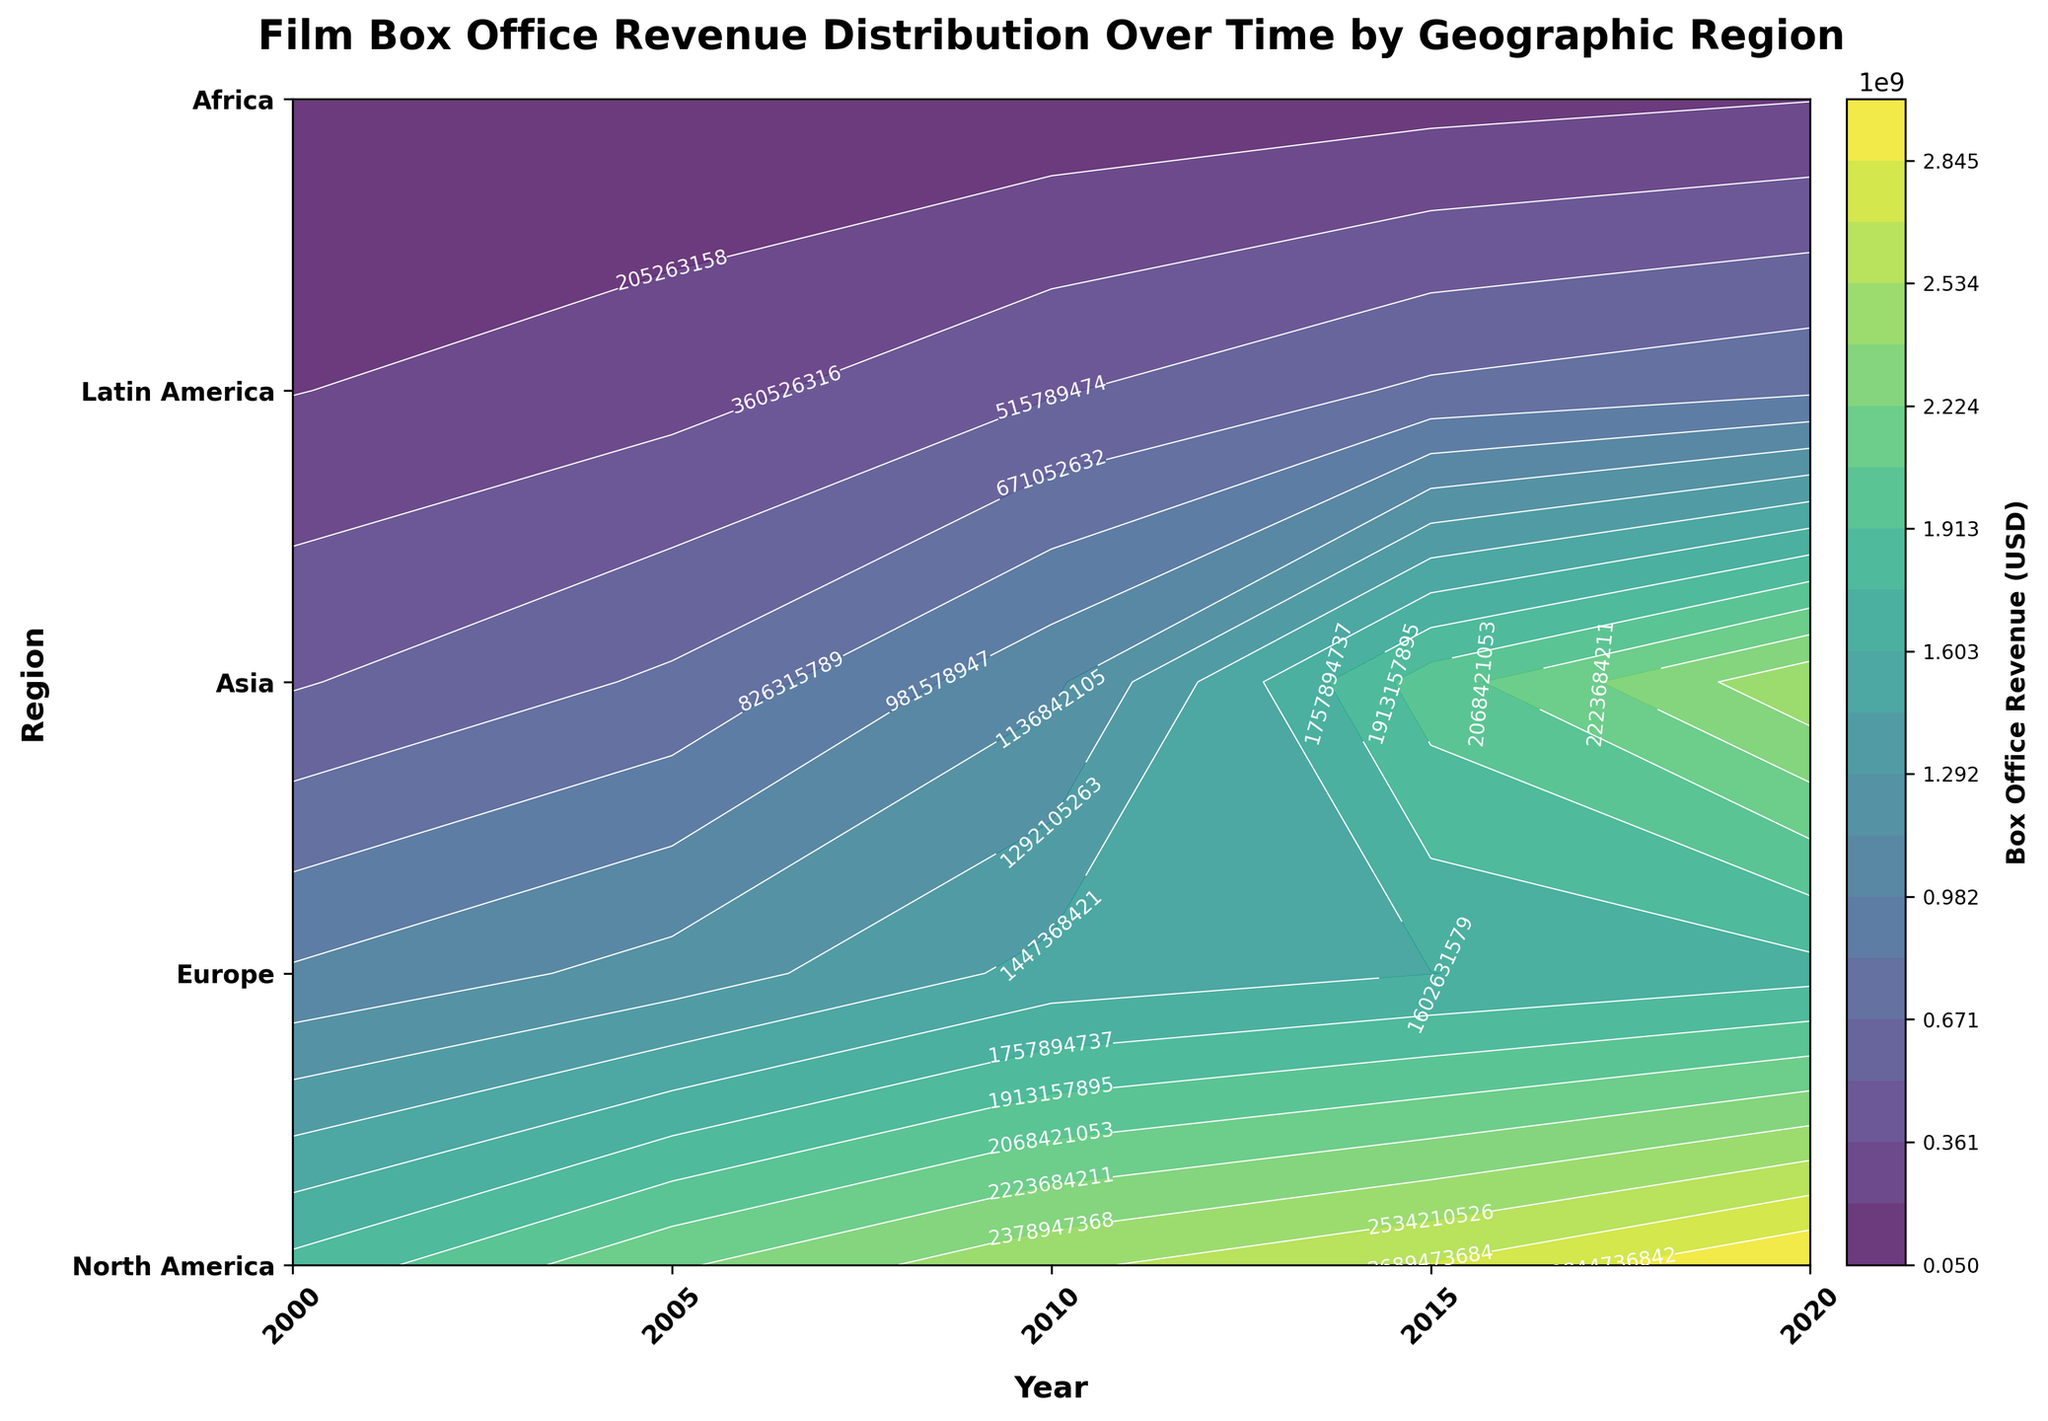What is the title of the plot? The title is usually the largest text at the top of the figure. It gives an overview of what the plot represents.
Answer: Film Box Office Revenue Distribution Over Time by Geographic Region Which region had the highest box office revenue in 2020? To find this, look at the box office revenue values along the 2020 axis and identify the highest value. Then find the corresponding region on the y-axis.
Answer: North America How did the box office revenue in Asia change from 2010 to 2020? Compare the contour levels or values of box office revenue for Asia between 2010 and 2020. Subtract the 2010 value from the 2020 value.
Answer: Increased Which year saw the highest revenue across all regions? Look for the year that has the highest maximum contour value among all regions combined.
Answer: 2020 What is the trend of box office revenue in Latin America from 2000 to 2020? Observe the contour levels for Latin America from 2000 to 2020. You can see the pattern of increase or decrease by comparing the values across the years.
Answer: Mostly increasing What region had the smallest increase in box office revenue from 2000 to 2020? Calculate the difference in box office revenue for each region from 2000 to 2020. Find the region with the smallest value.
Answer: Africa How does the box office revenue in Europe compare to Asia in 2015? Compare the contour levels or values of box office revenue in Europe and Asia in 2015. Look for which one is higher.
Answer: Europe is less than Asia Which regions show a consistent increase in box office revenue from 2000 to 2020? Analyze the contour levels for all regions across the given years. Identify regions with a steady upward trend throughout this period.
Answer: North America, Asia, Latin America Compare the box office revenue trend of North America and Europe from 2000 to 2020. Examine and compare the contour levels of box office revenue for North America and Europe over the years. Look at the changes in values to identify trends.
Answer: Both increase, but North America increases more What is the range of box office revenue values displayed in the contour plot? The range can be found by looking at the colorbar which shows the minimum and maximum contour levels or revenue values.
Answer: 50,000,000 to 3,000,000,000 